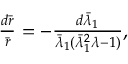Convert formula to latex. <formula><loc_0><loc_0><loc_500><loc_500>\begin{array} { r } { \frac { d \bar { r } } { \bar { r } } = - \frac { d \bar { \lambda } _ { 1 } } { \bar { \lambda } _ { 1 } ( \bar { \lambda } _ { 1 } ^ { 2 } \lambda - 1 ) } , } \end{array}</formula> 